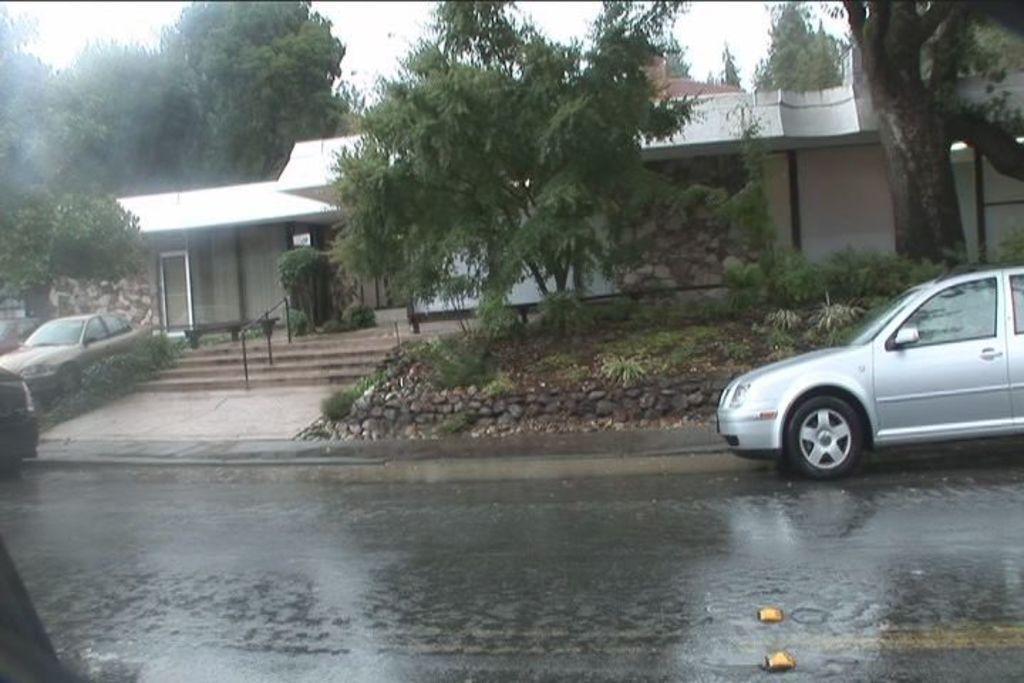How would you summarize this image in a sentence or two? In this image, I can see a house, trees, plants, rocks and stairs. On the left and right side of the image, I can see the vehicles on the road. In the background, there is the sky. 